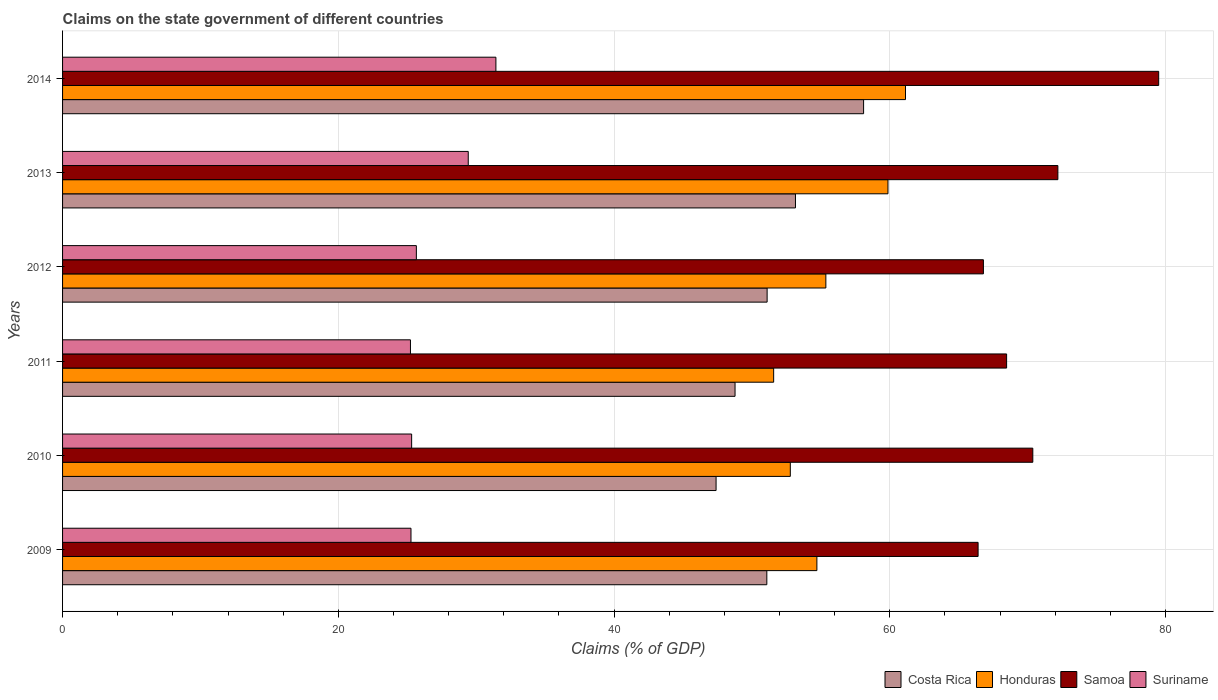How many different coloured bars are there?
Make the answer very short. 4. In how many cases, is the number of bars for a given year not equal to the number of legend labels?
Ensure brevity in your answer.  0. What is the percentage of GDP claimed on the state government in Costa Rica in 2011?
Provide a short and direct response. 48.77. Across all years, what is the maximum percentage of GDP claimed on the state government in Samoa?
Provide a short and direct response. 79.5. Across all years, what is the minimum percentage of GDP claimed on the state government in Suriname?
Your answer should be compact. 25.23. What is the total percentage of GDP claimed on the state government in Costa Rica in the graph?
Your response must be concise. 309.6. What is the difference between the percentage of GDP claimed on the state government in Honduras in 2012 and that in 2013?
Ensure brevity in your answer.  -4.51. What is the difference between the percentage of GDP claimed on the state government in Suriname in 2013 and the percentage of GDP claimed on the state government in Honduras in 2012?
Provide a short and direct response. -25.94. What is the average percentage of GDP claimed on the state government in Honduras per year?
Offer a terse response. 55.9. In the year 2011, what is the difference between the percentage of GDP claimed on the state government in Honduras and percentage of GDP claimed on the state government in Samoa?
Give a very brief answer. -16.89. What is the ratio of the percentage of GDP claimed on the state government in Samoa in 2010 to that in 2012?
Keep it short and to the point. 1.05. Is the percentage of GDP claimed on the state government in Samoa in 2010 less than that in 2013?
Ensure brevity in your answer.  Yes. What is the difference between the highest and the second highest percentage of GDP claimed on the state government in Costa Rica?
Give a very brief answer. 4.94. What is the difference between the highest and the lowest percentage of GDP claimed on the state government in Honduras?
Your response must be concise. 9.56. In how many years, is the percentage of GDP claimed on the state government in Suriname greater than the average percentage of GDP claimed on the state government in Suriname taken over all years?
Ensure brevity in your answer.  2. Is the sum of the percentage of GDP claimed on the state government in Honduras in 2010 and 2012 greater than the maximum percentage of GDP claimed on the state government in Suriname across all years?
Offer a very short reply. Yes. What does the 2nd bar from the top in 2009 represents?
Your answer should be very brief. Samoa. Is it the case that in every year, the sum of the percentage of GDP claimed on the state government in Suriname and percentage of GDP claimed on the state government in Samoa is greater than the percentage of GDP claimed on the state government in Costa Rica?
Your response must be concise. Yes. How many bars are there?
Your response must be concise. 24. What is the difference between two consecutive major ticks on the X-axis?
Keep it short and to the point. 20. Are the values on the major ticks of X-axis written in scientific E-notation?
Provide a short and direct response. No. Where does the legend appear in the graph?
Give a very brief answer. Bottom right. How many legend labels are there?
Provide a succinct answer. 4. What is the title of the graph?
Make the answer very short. Claims on the state government of different countries. Does "Romania" appear as one of the legend labels in the graph?
Give a very brief answer. No. What is the label or title of the X-axis?
Provide a short and direct response. Claims (% of GDP). What is the Claims (% of GDP) of Costa Rica in 2009?
Your response must be concise. 51.08. What is the Claims (% of GDP) of Honduras in 2009?
Make the answer very short. 54.71. What is the Claims (% of GDP) in Samoa in 2009?
Your answer should be compact. 66.4. What is the Claims (% of GDP) of Suriname in 2009?
Your response must be concise. 25.27. What is the Claims (% of GDP) in Costa Rica in 2010?
Make the answer very short. 47.4. What is the Claims (% of GDP) of Honduras in 2010?
Provide a succinct answer. 52.78. What is the Claims (% of GDP) of Samoa in 2010?
Keep it short and to the point. 70.37. What is the Claims (% of GDP) in Suriname in 2010?
Provide a succinct answer. 25.32. What is the Claims (% of GDP) of Costa Rica in 2011?
Your response must be concise. 48.77. What is the Claims (% of GDP) in Honduras in 2011?
Your answer should be compact. 51.57. What is the Claims (% of GDP) of Samoa in 2011?
Offer a terse response. 68.47. What is the Claims (% of GDP) in Suriname in 2011?
Give a very brief answer. 25.23. What is the Claims (% of GDP) in Costa Rica in 2012?
Give a very brief answer. 51.1. What is the Claims (% of GDP) of Honduras in 2012?
Give a very brief answer. 55.36. What is the Claims (% of GDP) of Samoa in 2012?
Your response must be concise. 66.79. What is the Claims (% of GDP) in Suriname in 2012?
Provide a short and direct response. 25.66. What is the Claims (% of GDP) in Costa Rica in 2013?
Give a very brief answer. 53.16. What is the Claims (% of GDP) in Honduras in 2013?
Provide a succinct answer. 59.86. What is the Claims (% of GDP) in Samoa in 2013?
Provide a short and direct response. 72.19. What is the Claims (% of GDP) in Suriname in 2013?
Your answer should be very brief. 29.42. What is the Claims (% of GDP) of Costa Rica in 2014?
Keep it short and to the point. 58.1. What is the Claims (% of GDP) in Honduras in 2014?
Give a very brief answer. 61.14. What is the Claims (% of GDP) in Samoa in 2014?
Your answer should be very brief. 79.5. What is the Claims (% of GDP) of Suriname in 2014?
Your answer should be very brief. 31.43. Across all years, what is the maximum Claims (% of GDP) of Costa Rica?
Offer a terse response. 58.1. Across all years, what is the maximum Claims (% of GDP) in Honduras?
Your answer should be very brief. 61.14. Across all years, what is the maximum Claims (% of GDP) of Samoa?
Give a very brief answer. 79.5. Across all years, what is the maximum Claims (% of GDP) in Suriname?
Provide a succinct answer. 31.43. Across all years, what is the minimum Claims (% of GDP) of Costa Rica?
Your answer should be compact. 47.4. Across all years, what is the minimum Claims (% of GDP) of Honduras?
Provide a succinct answer. 51.57. Across all years, what is the minimum Claims (% of GDP) of Samoa?
Offer a terse response. 66.4. Across all years, what is the minimum Claims (% of GDP) of Suriname?
Offer a very short reply. 25.23. What is the total Claims (% of GDP) in Costa Rica in the graph?
Offer a very short reply. 309.6. What is the total Claims (% of GDP) of Honduras in the graph?
Make the answer very short. 335.43. What is the total Claims (% of GDP) in Samoa in the graph?
Keep it short and to the point. 423.71. What is the total Claims (% of GDP) in Suriname in the graph?
Provide a succinct answer. 162.33. What is the difference between the Claims (% of GDP) in Costa Rica in 2009 and that in 2010?
Provide a succinct answer. 3.68. What is the difference between the Claims (% of GDP) in Honduras in 2009 and that in 2010?
Make the answer very short. 1.93. What is the difference between the Claims (% of GDP) of Samoa in 2009 and that in 2010?
Provide a succinct answer. -3.97. What is the difference between the Claims (% of GDP) in Suriname in 2009 and that in 2010?
Offer a very short reply. -0.05. What is the difference between the Claims (% of GDP) of Costa Rica in 2009 and that in 2011?
Offer a very short reply. 2.31. What is the difference between the Claims (% of GDP) of Honduras in 2009 and that in 2011?
Offer a very short reply. 3.14. What is the difference between the Claims (% of GDP) in Samoa in 2009 and that in 2011?
Ensure brevity in your answer.  -2.07. What is the difference between the Claims (% of GDP) in Suriname in 2009 and that in 2011?
Offer a terse response. 0.04. What is the difference between the Claims (% of GDP) of Costa Rica in 2009 and that in 2012?
Provide a succinct answer. -0.02. What is the difference between the Claims (% of GDP) in Honduras in 2009 and that in 2012?
Give a very brief answer. -0.65. What is the difference between the Claims (% of GDP) of Samoa in 2009 and that in 2012?
Give a very brief answer. -0.38. What is the difference between the Claims (% of GDP) of Suriname in 2009 and that in 2012?
Offer a very short reply. -0.39. What is the difference between the Claims (% of GDP) of Costa Rica in 2009 and that in 2013?
Offer a terse response. -2.08. What is the difference between the Claims (% of GDP) in Honduras in 2009 and that in 2013?
Provide a short and direct response. -5.16. What is the difference between the Claims (% of GDP) in Samoa in 2009 and that in 2013?
Your response must be concise. -5.79. What is the difference between the Claims (% of GDP) in Suriname in 2009 and that in 2013?
Offer a terse response. -4.15. What is the difference between the Claims (% of GDP) in Costa Rica in 2009 and that in 2014?
Provide a short and direct response. -7.02. What is the difference between the Claims (% of GDP) of Honduras in 2009 and that in 2014?
Your answer should be very brief. -6.43. What is the difference between the Claims (% of GDP) of Samoa in 2009 and that in 2014?
Offer a very short reply. -13.1. What is the difference between the Claims (% of GDP) in Suriname in 2009 and that in 2014?
Provide a short and direct response. -6.16. What is the difference between the Claims (% of GDP) of Costa Rica in 2010 and that in 2011?
Make the answer very short. -1.38. What is the difference between the Claims (% of GDP) in Honduras in 2010 and that in 2011?
Keep it short and to the point. 1.21. What is the difference between the Claims (% of GDP) of Samoa in 2010 and that in 2011?
Keep it short and to the point. 1.9. What is the difference between the Claims (% of GDP) in Suriname in 2010 and that in 2011?
Provide a short and direct response. 0.09. What is the difference between the Claims (% of GDP) in Costa Rica in 2010 and that in 2012?
Offer a terse response. -3.7. What is the difference between the Claims (% of GDP) of Honduras in 2010 and that in 2012?
Ensure brevity in your answer.  -2.58. What is the difference between the Claims (% of GDP) in Samoa in 2010 and that in 2012?
Your answer should be very brief. 3.58. What is the difference between the Claims (% of GDP) in Suriname in 2010 and that in 2012?
Offer a terse response. -0.34. What is the difference between the Claims (% of GDP) in Costa Rica in 2010 and that in 2013?
Keep it short and to the point. -5.76. What is the difference between the Claims (% of GDP) in Honduras in 2010 and that in 2013?
Your response must be concise. -7.08. What is the difference between the Claims (% of GDP) in Samoa in 2010 and that in 2013?
Your answer should be very brief. -1.82. What is the difference between the Claims (% of GDP) in Suriname in 2010 and that in 2013?
Offer a terse response. -4.11. What is the difference between the Claims (% of GDP) of Costa Rica in 2010 and that in 2014?
Ensure brevity in your answer.  -10.7. What is the difference between the Claims (% of GDP) of Honduras in 2010 and that in 2014?
Ensure brevity in your answer.  -8.35. What is the difference between the Claims (% of GDP) in Samoa in 2010 and that in 2014?
Offer a very short reply. -9.13. What is the difference between the Claims (% of GDP) in Suriname in 2010 and that in 2014?
Offer a very short reply. -6.11. What is the difference between the Claims (% of GDP) in Costa Rica in 2011 and that in 2012?
Your answer should be compact. -2.33. What is the difference between the Claims (% of GDP) in Honduras in 2011 and that in 2012?
Keep it short and to the point. -3.79. What is the difference between the Claims (% of GDP) in Samoa in 2011 and that in 2012?
Give a very brief answer. 1.68. What is the difference between the Claims (% of GDP) in Suriname in 2011 and that in 2012?
Your answer should be compact. -0.43. What is the difference between the Claims (% of GDP) in Costa Rica in 2011 and that in 2013?
Offer a terse response. -4.38. What is the difference between the Claims (% of GDP) of Honduras in 2011 and that in 2013?
Offer a terse response. -8.29. What is the difference between the Claims (% of GDP) in Samoa in 2011 and that in 2013?
Provide a short and direct response. -3.72. What is the difference between the Claims (% of GDP) of Suriname in 2011 and that in 2013?
Provide a short and direct response. -4.19. What is the difference between the Claims (% of GDP) in Costa Rica in 2011 and that in 2014?
Offer a very short reply. -9.32. What is the difference between the Claims (% of GDP) in Honduras in 2011 and that in 2014?
Your answer should be very brief. -9.56. What is the difference between the Claims (% of GDP) of Samoa in 2011 and that in 2014?
Provide a short and direct response. -11.03. What is the difference between the Claims (% of GDP) of Suriname in 2011 and that in 2014?
Your answer should be very brief. -6.2. What is the difference between the Claims (% of GDP) of Costa Rica in 2012 and that in 2013?
Your answer should be compact. -2.06. What is the difference between the Claims (% of GDP) of Honduras in 2012 and that in 2013?
Provide a short and direct response. -4.51. What is the difference between the Claims (% of GDP) of Samoa in 2012 and that in 2013?
Offer a terse response. -5.4. What is the difference between the Claims (% of GDP) of Suriname in 2012 and that in 2013?
Your answer should be very brief. -3.76. What is the difference between the Claims (% of GDP) of Costa Rica in 2012 and that in 2014?
Make the answer very short. -7. What is the difference between the Claims (% of GDP) in Honduras in 2012 and that in 2014?
Make the answer very short. -5.78. What is the difference between the Claims (% of GDP) of Samoa in 2012 and that in 2014?
Ensure brevity in your answer.  -12.71. What is the difference between the Claims (% of GDP) of Suriname in 2012 and that in 2014?
Your response must be concise. -5.77. What is the difference between the Claims (% of GDP) in Costa Rica in 2013 and that in 2014?
Give a very brief answer. -4.94. What is the difference between the Claims (% of GDP) in Honduras in 2013 and that in 2014?
Provide a short and direct response. -1.27. What is the difference between the Claims (% of GDP) of Samoa in 2013 and that in 2014?
Offer a terse response. -7.31. What is the difference between the Claims (% of GDP) in Suriname in 2013 and that in 2014?
Your answer should be compact. -2.01. What is the difference between the Claims (% of GDP) in Costa Rica in 2009 and the Claims (% of GDP) in Honduras in 2010?
Provide a short and direct response. -1.7. What is the difference between the Claims (% of GDP) of Costa Rica in 2009 and the Claims (% of GDP) of Samoa in 2010?
Offer a very short reply. -19.29. What is the difference between the Claims (% of GDP) in Costa Rica in 2009 and the Claims (% of GDP) in Suriname in 2010?
Offer a very short reply. 25.76. What is the difference between the Claims (% of GDP) of Honduras in 2009 and the Claims (% of GDP) of Samoa in 2010?
Offer a very short reply. -15.66. What is the difference between the Claims (% of GDP) of Honduras in 2009 and the Claims (% of GDP) of Suriname in 2010?
Your answer should be compact. 29.39. What is the difference between the Claims (% of GDP) in Samoa in 2009 and the Claims (% of GDP) in Suriname in 2010?
Provide a short and direct response. 41.08. What is the difference between the Claims (% of GDP) in Costa Rica in 2009 and the Claims (% of GDP) in Honduras in 2011?
Keep it short and to the point. -0.5. What is the difference between the Claims (% of GDP) of Costa Rica in 2009 and the Claims (% of GDP) of Samoa in 2011?
Make the answer very short. -17.39. What is the difference between the Claims (% of GDP) of Costa Rica in 2009 and the Claims (% of GDP) of Suriname in 2011?
Your answer should be very brief. 25.85. What is the difference between the Claims (% of GDP) of Honduras in 2009 and the Claims (% of GDP) of Samoa in 2011?
Make the answer very short. -13.76. What is the difference between the Claims (% of GDP) of Honduras in 2009 and the Claims (% of GDP) of Suriname in 2011?
Your answer should be compact. 29.48. What is the difference between the Claims (% of GDP) of Samoa in 2009 and the Claims (% of GDP) of Suriname in 2011?
Your answer should be compact. 41.17. What is the difference between the Claims (% of GDP) of Costa Rica in 2009 and the Claims (% of GDP) of Honduras in 2012?
Your response must be concise. -4.28. What is the difference between the Claims (% of GDP) of Costa Rica in 2009 and the Claims (% of GDP) of Samoa in 2012?
Your response must be concise. -15.71. What is the difference between the Claims (% of GDP) in Costa Rica in 2009 and the Claims (% of GDP) in Suriname in 2012?
Keep it short and to the point. 25.42. What is the difference between the Claims (% of GDP) in Honduras in 2009 and the Claims (% of GDP) in Samoa in 2012?
Offer a terse response. -12.08. What is the difference between the Claims (% of GDP) in Honduras in 2009 and the Claims (% of GDP) in Suriname in 2012?
Your answer should be very brief. 29.05. What is the difference between the Claims (% of GDP) of Samoa in 2009 and the Claims (% of GDP) of Suriname in 2012?
Offer a very short reply. 40.74. What is the difference between the Claims (% of GDP) of Costa Rica in 2009 and the Claims (% of GDP) of Honduras in 2013?
Offer a terse response. -8.79. What is the difference between the Claims (% of GDP) in Costa Rica in 2009 and the Claims (% of GDP) in Samoa in 2013?
Keep it short and to the point. -21.11. What is the difference between the Claims (% of GDP) of Costa Rica in 2009 and the Claims (% of GDP) of Suriname in 2013?
Make the answer very short. 21.66. What is the difference between the Claims (% of GDP) in Honduras in 2009 and the Claims (% of GDP) in Samoa in 2013?
Provide a short and direct response. -17.48. What is the difference between the Claims (% of GDP) of Honduras in 2009 and the Claims (% of GDP) of Suriname in 2013?
Provide a succinct answer. 25.29. What is the difference between the Claims (% of GDP) of Samoa in 2009 and the Claims (% of GDP) of Suriname in 2013?
Provide a succinct answer. 36.98. What is the difference between the Claims (% of GDP) in Costa Rica in 2009 and the Claims (% of GDP) in Honduras in 2014?
Your answer should be very brief. -10.06. What is the difference between the Claims (% of GDP) of Costa Rica in 2009 and the Claims (% of GDP) of Samoa in 2014?
Keep it short and to the point. -28.42. What is the difference between the Claims (% of GDP) of Costa Rica in 2009 and the Claims (% of GDP) of Suriname in 2014?
Offer a terse response. 19.65. What is the difference between the Claims (% of GDP) of Honduras in 2009 and the Claims (% of GDP) of Samoa in 2014?
Keep it short and to the point. -24.79. What is the difference between the Claims (% of GDP) in Honduras in 2009 and the Claims (% of GDP) in Suriname in 2014?
Offer a terse response. 23.28. What is the difference between the Claims (% of GDP) of Samoa in 2009 and the Claims (% of GDP) of Suriname in 2014?
Make the answer very short. 34.97. What is the difference between the Claims (% of GDP) of Costa Rica in 2010 and the Claims (% of GDP) of Honduras in 2011?
Provide a short and direct response. -4.18. What is the difference between the Claims (% of GDP) in Costa Rica in 2010 and the Claims (% of GDP) in Samoa in 2011?
Provide a short and direct response. -21.07. What is the difference between the Claims (% of GDP) of Costa Rica in 2010 and the Claims (% of GDP) of Suriname in 2011?
Provide a succinct answer. 22.17. What is the difference between the Claims (% of GDP) in Honduras in 2010 and the Claims (% of GDP) in Samoa in 2011?
Your response must be concise. -15.69. What is the difference between the Claims (% of GDP) in Honduras in 2010 and the Claims (% of GDP) in Suriname in 2011?
Give a very brief answer. 27.55. What is the difference between the Claims (% of GDP) of Samoa in 2010 and the Claims (% of GDP) of Suriname in 2011?
Your response must be concise. 45.14. What is the difference between the Claims (% of GDP) of Costa Rica in 2010 and the Claims (% of GDP) of Honduras in 2012?
Your answer should be very brief. -7.96. What is the difference between the Claims (% of GDP) in Costa Rica in 2010 and the Claims (% of GDP) in Samoa in 2012?
Ensure brevity in your answer.  -19.39. What is the difference between the Claims (% of GDP) of Costa Rica in 2010 and the Claims (% of GDP) of Suriname in 2012?
Offer a terse response. 21.74. What is the difference between the Claims (% of GDP) of Honduras in 2010 and the Claims (% of GDP) of Samoa in 2012?
Your answer should be very brief. -14. What is the difference between the Claims (% of GDP) of Honduras in 2010 and the Claims (% of GDP) of Suriname in 2012?
Offer a very short reply. 27.12. What is the difference between the Claims (% of GDP) of Samoa in 2010 and the Claims (% of GDP) of Suriname in 2012?
Your response must be concise. 44.71. What is the difference between the Claims (% of GDP) of Costa Rica in 2010 and the Claims (% of GDP) of Honduras in 2013?
Your answer should be very brief. -12.47. What is the difference between the Claims (% of GDP) of Costa Rica in 2010 and the Claims (% of GDP) of Samoa in 2013?
Provide a short and direct response. -24.79. What is the difference between the Claims (% of GDP) of Costa Rica in 2010 and the Claims (% of GDP) of Suriname in 2013?
Provide a succinct answer. 17.97. What is the difference between the Claims (% of GDP) in Honduras in 2010 and the Claims (% of GDP) in Samoa in 2013?
Make the answer very short. -19.41. What is the difference between the Claims (% of GDP) of Honduras in 2010 and the Claims (% of GDP) of Suriname in 2013?
Keep it short and to the point. 23.36. What is the difference between the Claims (% of GDP) of Samoa in 2010 and the Claims (% of GDP) of Suriname in 2013?
Provide a succinct answer. 40.95. What is the difference between the Claims (% of GDP) of Costa Rica in 2010 and the Claims (% of GDP) of Honduras in 2014?
Provide a succinct answer. -13.74. What is the difference between the Claims (% of GDP) of Costa Rica in 2010 and the Claims (% of GDP) of Samoa in 2014?
Keep it short and to the point. -32.1. What is the difference between the Claims (% of GDP) of Costa Rica in 2010 and the Claims (% of GDP) of Suriname in 2014?
Offer a very short reply. 15.97. What is the difference between the Claims (% of GDP) in Honduras in 2010 and the Claims (% of GDP) in Samoa in 2014?
Your answer should be very brief. -26.72. What is the difference between the Claims (% of GDP) in Honduras in 2010 and the Claims (% of GDP) in Suriname in 2014?
Give a very brief answer. 21.35. What is the difference between the Claims (% of GDP) in Samoa in 2010 and the Claims (% of GDP) in Suriname in 2014?
Offer a very short reply. 38.94. What is the difference between the Claims (% of GDP) in Costa Rica in 2011 and the Claims (% of GDP) in Honduras in 2012?
Ensure brevity in your answer.  -6.59. What is the difference between the Claims (% of GDP) in Costa Rica in 2011 and the Claims (% of GDP) in Samoa in 2012?
Your answer should be compact. -18.01. What is the difference between the Claims (% of GDP) of Costa Rica in 2011 and the Claims (% of GDP) of Suriname in 2012?
Provide a short and direct response. 23.11. What is the difference between the Claims (% of GDP) of Honduras in 2011 and the Claims (% of GDP) of Samoa in 2012?
Offer a terse response. -15.21. What is the difference between the Claims (% of GDP) in Honduras in 2011 and the Claims (% of GDP) in Suriname in 2012?
Your response must be concise. 25.91. What is the difference between the Claims (% of GDP) in Samoa in 2011 and the Claims (% of GDP) in Suriname in 2012?
Offer a terse response. 42.81. What is the difference between the Claims (% of GDP) in Costa Rica in 2011 and the Claims (% of GDP) in Honduras in 2013?
Provide a succinct answer. -11.09. What is the difference between the Claims (% of GDP) of Costa Rica in 2011 and the Claims (% of GDP) of Samoa in 2013?
Your answer should be very brief. -23.41. What is the difference between the Claims (% of GDP) of Costa Rica in 2011 and the Claims (% of GDP) of Suriname in 2013?
Provide a short and direct response. 19.35. What is the difference between the Claims (% of GDP) in Honduras in 2011 and the Claims (% of GDP) in Samoa in 2013?
Ensure brevity in your answer.  -20.61. What is the difference between the Claims (% of GDP) in Honduras in 2011 and the Claims (% of GDP) in Suriname in 2013?
Offer a very short reply. 22.15. What is the difference between the Claims (% of GDP) in Samoa in 2011 and the Claims (% of GDP) in Suriname in 2013?
Make the answer very short. 39.05. What is the difference between the Claims (% of GDP) of Costa Rica in 2011 and the Claims (% of GDP) of Honduras in 2014?
Offer a very short reply. -12.36. What is the difference between the Claims (% of GDP) in Costa Rica in 2011 and the Claims (% of GDP) in Samoa in 2014?
Make the answer very short. -30.73. What is the difference between the Claims (% of GDP) of Costa Rica in 2011 and the Claims (% of GDP) of Suriname in 2014?
Offer a very short reply. 17.34. What is the difference between the Claims (% of GDP) in Honduras in 2011 and the Claims (% of GDP) in Samoa in 2014?
Your answer should be compact. -27.93. What is the difference between the Claims (% of GDP) of Honduras in 2011 and the Claims (% of GDP) of Suriname in 2014?
Your response must be concise. 20.14. What is the difference between the Claims (% of GDP) in Samoa in 2011 and the Claims (% of GDP) in Suriname in 2014?
Your answer should be very brief. 37.04. What is the difference between the Claims (% of GDP) of Costa Rica in 2012 and the Claims (% of GDP) of Honduras in 2013?
Make the answer very short. -8.76. What is the difference between the Claims (% of GDP) of Costa Rica in 2012 and the Claims (% of GDP) of Samoa in 2013?
Make the answer very short. -21.09. What is the difference between the Claims (% of GDP) in Costa Rica in 2012 and the Claims (% of GDP) in Suriname in 2013?
Keep it short and to the point. 21.68. What is the difference between the Claims (% of GDP) in Honduras in 2012 and the Claims (% of GDP) in Samoa in 2013?
Provide a short and direct response. -16.83. What is the difference between the Claims (% of GDP) in Honduras in 2012 and the Claims (% of GDP) in Suriname in 2013?
Provide a short and direct response. 25.94. What is the difference between the Claims (% of GDP) of Samoa in 2012 and the Claims (% of GDP) of Suriname in 2013?
Provide a succinct answer. 37.36. What is the difference between the Claims (% of GDP) of Costa Rica in 2012 and the Claims (% of GDP) of Honduras in 2014?
Make the answer very short. -10.04. What is the difference between the Claims (% of GDP) in Costa Rica in 2012 and the Claims (% of GDP) in Samoa in 2014?
Your answer should be very brief. -28.4. What is the difference between the Claims (% of GDP) in Costa Rica in 2012 and the Claims (% of GDP) in Suriname in 2014?
Give a very brief answer. 19.67. What is the difference between the Claims (% of GDP) of Honduras in 2012 and the Claims (% of GDP) of Samoa in 2014?
Offer a terse response. -24.14. What is the difference between the Claims (% of GDP) of Honduras in 2012 and the Claims (% of GDP) of Suriname in 2014?
Ensure brevity in your answer.  23.93. What is the difference between the Claims (% of GDP) of Samoa in 2012 and the Claims (% of GDP) of Suriname in 2014?
Your answer should be compact. 35.36. What is the difference between the Claims (% of GDP) of Costa Rica in 2013 and the Claims (% of GDP) of Honduras in 2014?
Ensure brevity in your answer.  -7.98. What is the difference between the Claims (% of GDP) in Costa Rica in 2013 and the Claims (% of GDP) in Samoa in 2014?
Your answer should be very brief. -26.34. What is the difference between the Claims (% of GDP) in Costa Rica in 2013 and the Claims (% of GDP) in Suriname in 2014?
Ensure brevity in your answer.  21.73. What is the difference between the Claims (% of GDP) in Honduras in 2013 and the Claims (% of GDP) in Samoa in 2014?
Offer a terse response. -19.63. What is the difference between the Claims (% of GDP) of Honduras in 2013 and the Claims (% of GDP) of Suriname in 2014?
Offer a very short reply. 28.44. What is the difference between the Claims (% of GDP) of Samoa in 2013 and the Claims (% of GDP) of Suriname in 2014?
Offer a terse response. 40.76. What is the average Claims (% of GDP) in Costa Rica per year?
Make the answer very short. 51.6. What is the average Claims (% of GDP) of Honduras per year?
Provide a succinct answer. 55.9. What is the average Claims (% of GDP) of Samoa per year?
Your answer should be compact. 70.62. What is the average Claims (% of GDP) of Suriname per year?
Offer a very short reply. 27.06. In the year 2009, what is the difference between the Claims (% of GDP) of Costa Rica and Claims (% of GDP) of Honduras?
Offer a very short reply. -3.63. In the year 2009, what is the difference between the Claims (% of GDP) in Costa Rica and Claims (% of GDP) in Samoa?
Your answer should be very brief. -15.32. In the year 2009, what is the difference between the Claims (% of GDP) of Costa Rica and Claims (% of GDP) of Suriname?
Your response must be concise. 25.81. In the year 2009, what is the difference between the Claims (% of GDP) in Honduras and Claims (% of GDP) in Samoa?
Your response must be concise. -11.69. In the year 2009, what is the difference between the Claims (% of GDP) of Honduras and Claims (% of GDP) of Suriname?
Provide a succinct answer. 29.44. In the year 2009, what is the difference between the Claims (% of GDP) in Samoa and Claims (% of GDP) in Suriname?
Give a very brief answer. 41.13. In the year 2010, what is the difference between the Claims (% of GDP) of Costa Rica and Claims (% of GDP) of Honduras?
Make the answer very short. -5.38. In the year 2010, what is the difference between the Claims (% of GDP) of Costa Rica and Claims (% of GDP) of Samoa?
Give a very brief answer. -22.97. In the year 2010, what is the difference between the Claims (% of GDP) of Costa Rica and Claims (% of GDP) of Suriname?
Your response must be concise. 22.08. In the year 2010, what is the difference between the Claims (% of GDP) of Honduras and Claims (% of GDP) of Samoa?
Give a very brief answer. -17.59. In the year 2010, what is the difference between the Claims (% of GDP) of Honduras and Claims (% of GDP) of Suriname?
Your answer should be compact. 27.46. In the year 2010, what is the difference between the Claims (% of GDP) of Samoa and Claims (% of GDP) of Suriname?
Provide a succinct answer. 45.05. In the year 2011, what is the difference between the Claims (% of GDP) of Costa Rica and Claims (% of GDP) of Honduras?
Provide a succinct answer. -2.8. In the year 2011, what is the difference between the Claims (% of GDP) in Costa Rica and Claims (% of GDP) in Samoa?
Ensure brevity in your answer.  -19.7. In the year 2011, what is the difference between the Claims (% of GDP) in Costa Rica and Claims (% of GDP) in Suriname?
Give a very brief answer. 23.54. In the year 2011, what is the difference between the Claims (% of GDP) of Honduras and Claims (% of GDP) of Samoa?
Your answer should be very brief. -16.89. In the year 2011, what is the difference between the Claims (% of GDP) in Honduras and Claims (% of GDP) in Suriname?
Provide a succinct answer. 26.34. In the year 2011, what is the difference between the Claims (% of GDP) in Samoa and Claims (% of GDP) in Suriname?
Ensure brevity in your answer.  43.24. In the year 2012, what is the difference between the Claims (% of GDP) of Costa Rica and Claims (% of GDP) of Honduras?
Ensure brevity in your answer.  -4.26. In the year 2012, what is the difference between the Claims (% of GDP) of Costa Rica and Claims (% of GDP) of Samoa?
Give a very brief answer. -15.69. In the year 2012, what is the difference between the Claims (% of GDP) of Costa Rica and Claims (% of GDP) of Suriname?
Offer a terse response. 25.44. In the year 2012, what is the difference between the Claims (% of GDP) of Honduras and Claims (% of GDP) of Samoa?
Provide a succinct answer. -11.43. In the year 2012, what is the difference between the Claims (% of GDP) in Honduras and Claims (% of GDP) in Suriname?
Ensure brevity in your answer.  29.7. In the year 2012, what is the difference between the Claims (% of GDP) of Samoa and Claims (% of GDP) of Suriname?
Make the answer very short. 41.13. In the year 2013, what is the difference between the Claims (% of GDP) in Costa Rica and Claims (% of GDP) in Honduras?
Your answer should be compact. -6.71. In the year 2013, what is the difference between the Claims (% of GDP) in Costa Rica and Claims (% of GDP) in Samoa?
Provide a succinct answer. -19.03. In the year 2013, what is the difference between the Claims (% of GDP) of Costa Rica and Claims (% of GDP) of Suriname?
Make the answer very short. 23.73. In the year 2013, what is the difference between the Claims (% of GDP) of Honduras and Claims (% of GDP) of Samoa?
Your answer should be compact. -12.32. In the year 2013, what is the difference between the Claims (% of GDP) of Honduras and Claims (% of GDP) of Suriname?
Ensure brevity in your answer.  30.44. In the year 2013, what is the difference between the Claims (% of GDP) of Samoa and Claims (% of GDP) of Suriname?
Offer a terse response. 42.76. In the year 2014, what is the difference between the Claims (% of GDP) of Costa Rica and Claims (% of GDP) of Honduras?
Keep it short and to the point. -3.04. In the year 2014, what is the difference between the Claims (% of GDP) of Costa Rica and Claims (% of GDP) of Samoa?
Your answer should be very brief. -21.4. In the year 2014, what is the difference between the Claims (% of GDP) in Costa Rica and Claims (% of GDP) in Suriname?
Keep it short and to the point. 26.67. In the year 2014, what is the difference between the Claims (% of GDP) in Honduras and Claims (% of GDP) in Samoa?
Make the answer very short. -18.36. In the year 2014, what is the difference between the Claims (% of GDP) in Honduras and Claims (% of GDP) in Suriname?
Keep it short and to the point. 29.71. In the year 2014, what is the difference between the Claims (% of GDP) of Samoa and Claims (% of GDP) of Suriname?
Keep it short and to the point. 48.07. What is the ratio of the Claims (% of GDP) of Costa Rica in 2009 to that in 2010?
Provide a succinct answer. 1.08. What is the ratio of the Claims (% of GDP) in Honduras in 2009 to that in 2010?
Give a very brief answer. 1.04. What is the ratio of the Claims (% of GDP) in Samoa in 2009 to that in 2010?
Your answer should be compact. 0.94. What is the ratio of the Claims (% of GDP) in Suriname in 2009 to that in 2010?
Offer a very short reply. 1. What is the ratio of the Claims (% of GDP) in Costa Rica in 2009 to that in 2011?
Give a very brief answer. 1.05. What is the ratio of the Claims (% of GDP) of Honduras in 2009 to that in 2011?
Your response must be concise. 1.06. What is the ratio of the Claims (% of GDP) of Samoa in 2009 to that in 2011?
Keep it short and to the point. 0.97. What is the ratio of the Claims (% of GDP) in Suriname in 2009 to that in 2011?
Your answer should be compact. 1. What is the ratio of the Claims (% of GDP) in Honduras in 2009 to that in 2012?
Offer a very short reply. 0.99. What is the ratio of the Claims (% of GDP) in Samoa in 2009 to that in 2012?
Make the answer very short. 0.99. What is the ratio of the Claims (% of GDP) of Costa Rica in 2009 to that in 2013?
Your response must be concise. 0.96. What is the ratio of the Claims (% of GDP) in Honduras in 2009 to that in 2013?
Your response must be concise. 0.91. What is the ratio of the Claims (% of GDP) in Samoa in 2009 to that in 2013?
Make the answer very short. 0.92. What is the ratio of the Claims (% of GDP) of Suriname in 2009 to that in 2013?
Your response must be concise. 0.86. What is the ratio of the Claims (% of GDP) of Costa Rica in 2009 to that in 2014?
Your answer should be compact. 0.88. What is the ratio of the Claims (% of GDP) of Honduras in 2009 to that in 2014?
Your answer should be compact. 0.89. What is the ratio of the Claims (% of GDP) in Samoa in 2009 to that in 2014?
Your answer should be very brief. 0.84. What is the ratio of the Claims (% of GDP) of Suriname in 2009 to that in 2014?
Your answer should be very brief. 0.8. What is the ratio of the Claims (% of GDP) of Costa Rica in 2010 to that in 2011?
Provide a short and direct response. 0.97. What is the ratio of the Claims (% of GDP) in Honduras in 2010 to that in 2011?
Provide a succinct answer. 1.02. What is the ratio of the Claims (% of GDP) of Samoa in 2010 to that in 2011?
Your answer should be very brief. 1.03. What is the ratio of the Claims (% of GDP) in Costa Rica in 2010 to that in 2012?
Offer a terse response. 0.93. What is the ratio of the Claims (% of GDP) in Honduras in 2010 to that in 2012?
Your response must be concise. 0.95. What is the ratio of the Claims (% of GDP) of Samoa in 2010 to that in 2012?
Offer a terse response. 1.05. What is the ratio of the Claims (% of GDP) of Suriname in 2010 to that in 2012?
Offer a terse response. 0.99. What is the ratio of the Claims (% of GDP) of Costa Rica in 2010 to that in 2013?
Your response must be concise. 0.89. What is the ratio of the Claims (% of GDP) of Honduras in 2010 to that in 2013?
Provide a succinct answer. 0.88. What is the ratio of the Claims (% of GDP) of Samoa in 2010 to that in 2013?
Your answer should be very brief. 0.97. What is the ratio of the Claims (% of GDP) of Suriname in 2010 to that in 2013?
Provide a short and direct response. 0.86. What is the ratio of the Claims (% of GDP) in Costa Rica in 2010 to that in 2014?
Your response must be concise. 0.82. What is the ratio of the Claims (% of GDP) in Honduras in 2010 to that in 2014?
Provide a succinct answer. 0.86. What is the ratio of the Claims (% of GDP) in Samoa in 2010 to that in 2014?
Offer a very short reply. 0.89. What is the ratio of the Claims (% of GDP) of Suriname in 2010 to that in 2014?
Provide a succinct answer. 0.81. What is the ratio of the Claims (% of GDP) in Costa Rica in 2011 to that in 2012?
Your answer should be very brief. 0.95. What is the ratio of the Claims (% of GDP) in Honduras in 2011 to that in 2012?
Provide a short and direct response. 0.93. What is the ratio of the Claims (% of GDP) of Samoa in 2011 to that in 2012?
Provide a succinct answer. 1.03. What is the ratio of the Claims (% of GDP) in Suriname in 2011 to that in 2012?
Your response must be concise. 0.98. What is the ratio of the Claims (% of GDP) of Costa Rica in 2011 to that in 2013?
Keep it short and to the point. 0.92. What is the ratio of the Claims (% of GDP) in Honduras in 2011 to that in 2013?
Your answer should be very brief. 0.86. What is the ratio of the Claims (% of GDP) of Samoa in 2011 to that in 2013?
Offer a terse response. 0.95. What is the ratio of the Claims (% of GDP) in Suriname in 2011 to that in 2013?
Provide a succinct answer. 0.86. What is the ratio of the Claims (% of GDP) of Costa Rica in 2011 to that in 2014?
Your answer should be very brief. 0.84. What is the ratio of the Claims (% of GDP) in Honduras in 2011 to that in 2014?
Offer a terse response. 0.84. What is the ratio of the Claims (% of GDP) of Samoa in 2011 to that in 2014?
Your answer should be very brief. 0.86. What is the ratio of the Claims (% of GDP) of Suriname in 2011 to that in 2014?
Your response must be concise. 0.8. What is the ratio of the Claims (% of GDP) in Costa Rica in 2012 to that in 2013?
Make the answer very short. 0.96. What is the ratio of the Claims (% of GDP) in Honduras in 2012 to that in 2013?
Offer a very short reply. 0.92. What is the ratio of the Claims (% of GDP) in Samoa in 2012 to that in 2013?
Give a very brief answer. 0.93. What is the ratio of the Claims (% of GDP) of Suriname in 2012 to that in 2013?
Make the answer very short. 0.87. What is the ratio of the Claims (% of GDP) in Costa Rica in 2012 to that in 2014?
Give a very brief answer. 0.88. What is the ratio of the Claims (% of GDP) of Honduras in 2012 to that in 2014?
Your response must be concise. 0.91. What is the ratio of the Claims (% of GDP) of Samoa in 2012 to that in 2014?
Your answer should be compact. 0.84. What is the ratio of the Claims (% of GDP) in Suriname in 2012 to that in 2014?
Keep it short and to the point. 0.82. What is the ratio of the Claims (% of GDP) of Costa Rica in 2013 to that in 2014?
Offer a very short reply. 0.92. What is the ratio of the Claims (% of GDP) of Honduras in 2013 to that in 2014?
Ensure brevity in your answer.  0.98. What is the ratio of the Claims (% of GDP) in Samoa in 2013 to that in 2014?
Offer a terse response. 0.91. What is the ratio of the Claims (% of GDP) in Suriname in 2013 to that in 2014?
Offer a terse response. 0.94. What is the difference between the highest and the second highest Claims (% of GDP) of Costa Rica?
Ensure brevity in your answer.  4.94. What is the difference between the highest and the second highest Claims (% of GDP) in Honduras?
Make the answer very short. 1.27. What is the difference between the highest and the second highest Claims (% of GDP) of Samoa?
Offer a very short reply. 7.31. What is the difference between the highest and the second highest Claims (% of GDP) in Suriname?
Make the answer very short. 2.01. What is the difference between the highest and the lowest Claims (% of GDP) of Costa Rica?
Ensure brevity in your answer.  10.7. What is the difference between the highest and the lowest Claims (% of GDP) of Honduras?
Your answer should be very brief. 9.56. What is the difference between the highest and the lowest Claims (% of GDP) in Samoa?
Offer a terse response. 13.1. What is the difference between the highest and the lowest Claims (% of GDP) of Suriname?
Make the answer very short. 6.2. 